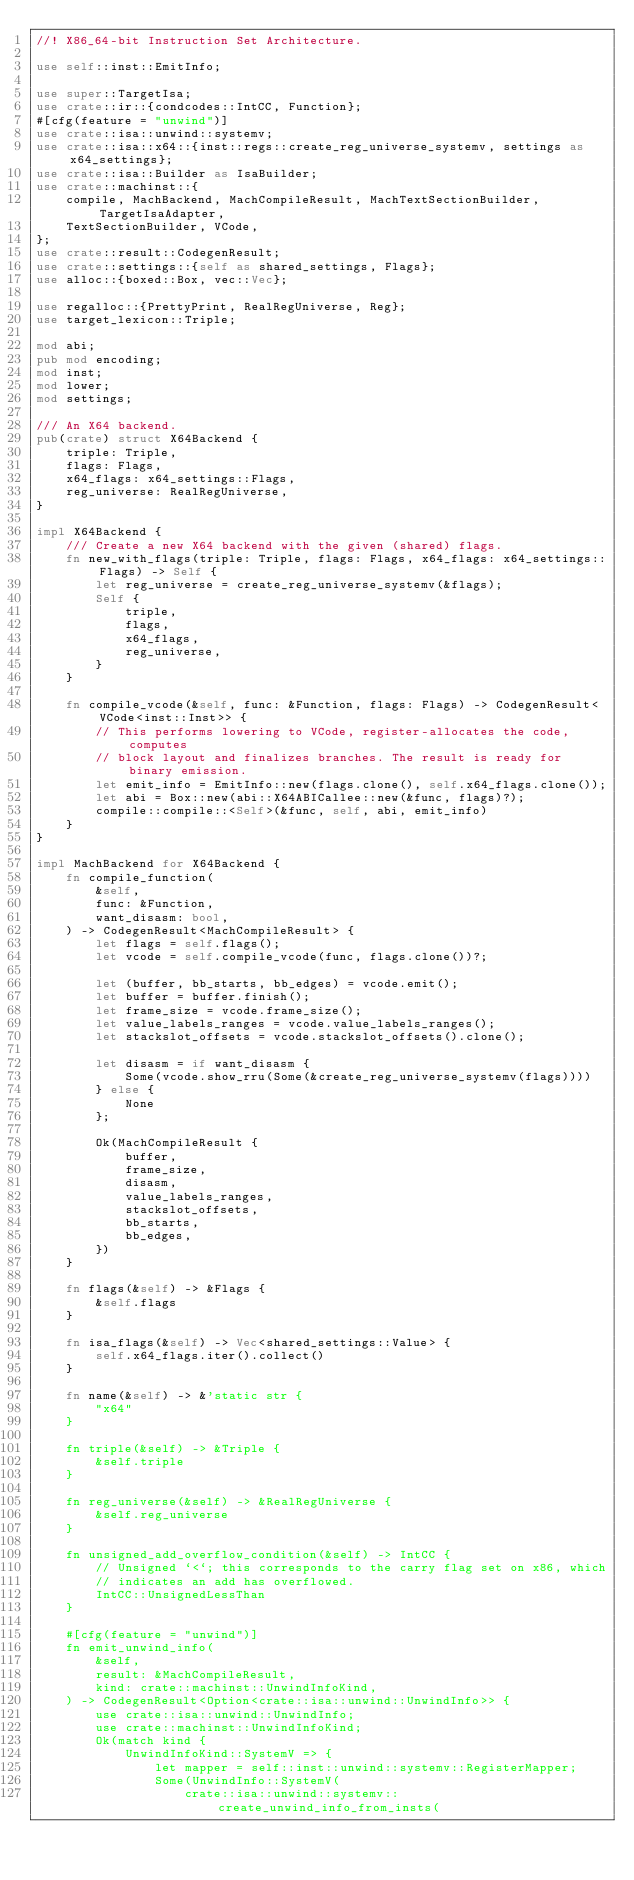Convert code to text. <code><loc_0><loc_0><loc_500><loc_500><_Rust_>//! X86_64-bit Instruction Set Architecture.

use self::inst::EmitInfo;

use super::TargetIsa;
use crate::ir::{condcodes::IntCC, Function};
#[cfg(feature = "unwind")]
use crate::isa::unwind::systemv;
use crate::isa::x64::{inst::regs::create_reg_universe_systemv, settings as x64_settings};
use crate::isa::Builder as IsaBuilder;
use crate::machinst::{
    compile, MachBackend, MachCompileResult, MachTextSectionBuilder, TargetIsaAdapter,
    TextSectionBuilder, VCode,
};
use crate::result::CodegenResult;
use crate::settings::{self as shared_settings, Flags};
use alloc::{boxed::Box, vec::Vec};

use regalloc::{PrettyPrint, RealRegUniverse, Reg};
use target_lexicon::Triple;

mod abi;
pub mod encoding;
mod inst;
mod lower;
mod settings;

/// An X64 backend.
pub(crate) struct X64Backend {
    triple: Triple,
    flags: Flags,
    x64_flags: x64_settings::Flags,
    reg_universe: RealRegUniverse,
}

impl X64Backend {
    /// Create a new X64 backend with the given (shared) flags.
    fn new_with_flags(triple: Triple, flags: Flags, x64_flags: x64_settings::Flags) -> Self {
        let reg_universe = create_reg_universe_systemv(&flags);
        Self {
            triple,
            flags,
            x64_flags,
            reg_universe,
        }
    }

    fn compile_vcode(&self, func: &Function, flags: Flags) -> CodegenResult<VCode<inst::Inst>> {
        // This performs lowering to VCode, register-allocates the code, computes
        // block layout and finalizes branches. The result is ready for binary emission.
        let emit_info = EmitInfo::new(flags.clone(), self.x64_flags.clone());
        let abi = Box::new(abi::X64ABICallee::new(&func, flags)?);
        compile::compile::<Self>(&func, self, abi, emit_info)
    }
}

impl MachBackend for X64Backend {
    fn compile_function(
        &self,
        func: &Function,
        want_disasm: bool,
    ) -> CodegenResult<MachCompileResult> {
        let flags = self.flags();
        let vcode = self.compile_vcode(func, flags.clone())?;

        let (buffer, bb_starts, bb_edges) = vcode.emit();
        let buffer = buffer.finish();
        let frame_size = vcode.frame_size();
        let value_labels_ranges = vcode.value_labels_ranges();
        let stackslot_offsets = vcode.stackslot_offsets().clone();

        let disasm = if want_disasm {
            Some(vcode.show_rru(Some(&create_reg_universe_systemv(flags))))
        } else {
            None
        };

        Ok(MachCompileResult {
            buffer,
            frame_size,
            disasm,
            value_labels_ranges,
            stackslot_offsets,
            bb_starts,
            bb_edges,
        })
    }

    fn flags(&self) -> &Flags {
        &self.flags
    }

    fn isa_flags(&self) -> Vec<shared_settings::Value> {
        self.x64_flags.iter().collect()
    }

    fn name(&self) -> &'static str {
        "x64"
    }

    fn triple(&self) -> &Triple {
        &self.triple
    }

    fn reg_universe(&self) -> &RealRegUniverse {
        &self.reg_universe
    }

    fn unsigned_add_overflow_condition(&self) -> IntCC {
        // Unsigned `<`; this corresponds to the carry flag set on x86, which
        // indicates an add has overflowed.
        IntCC::UnsignedLessThan
    }

    #[cfg(feature = "unwind")]
    fn emit_unwind_info(
        &self,
        result: &MachCompileResult,
        kind: crate::machinst::UnwindInfoKind,
    ) -> CodegenResult<Option<crate::isa::unwind::UnwindInfo>> {
        use crate::isa::unwind::UnwindInfo;
        use crate::machinst::UnwindInfoKind;
        Ok(match kind {
            UnwindInfoKind::SystemV => {
                let mapper = self::inst::unwind::systemv::RegisterMapper;
                Some(UnwindInfo::SystemV(
                    crate::isa::unwind::systemv::create_unwind_info_from_insts(</code> 